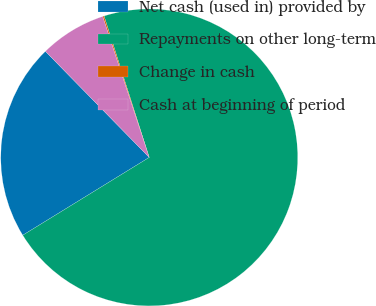Convert chart. <chart><loc_0><loc_0><loc_500><loc_500><pie_chart><fcel>Net cash (used in) provided by<fcel>Repayments on other long-term<fcel>Change in cash<fcel>Cash at beginning of period<nl><fcel>21.45%<fcel>71.14%<fcel>0.15%<fcel>7.25%<nl></chart> 